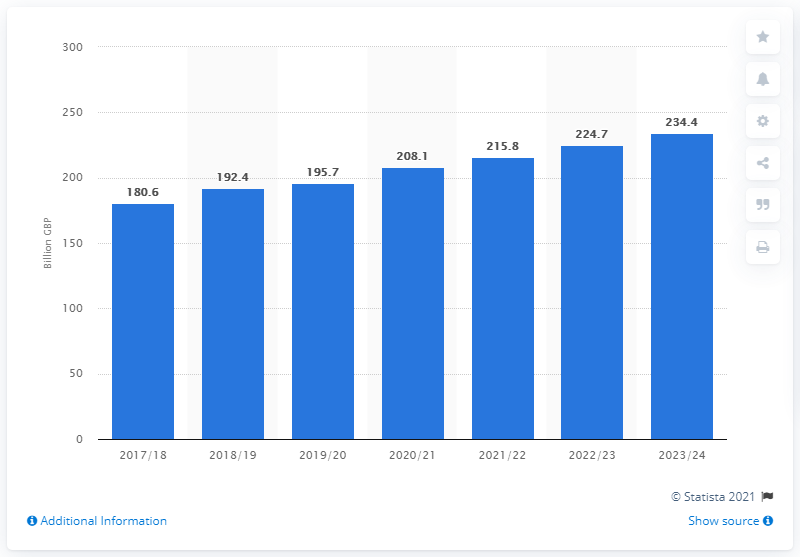Indicate a few pertinent items in this graphic. The estimated increase in income tax in the United Kingdom for the year 2023/24 is 234.4%. According to the government's projections for the fiscal year 2017/18, it is expected to receive an income tax revenue of 180.6... 